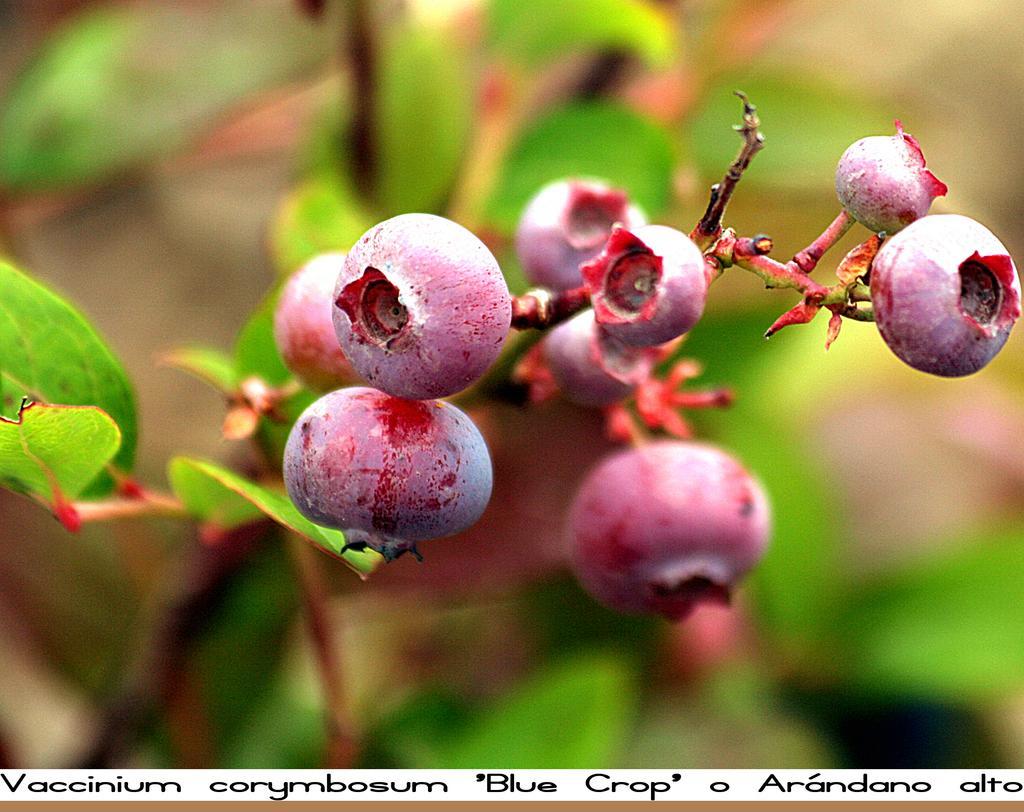Please provide a concise description of this image. As we can see in the image there are plants and fruits. The background is little blurred. 